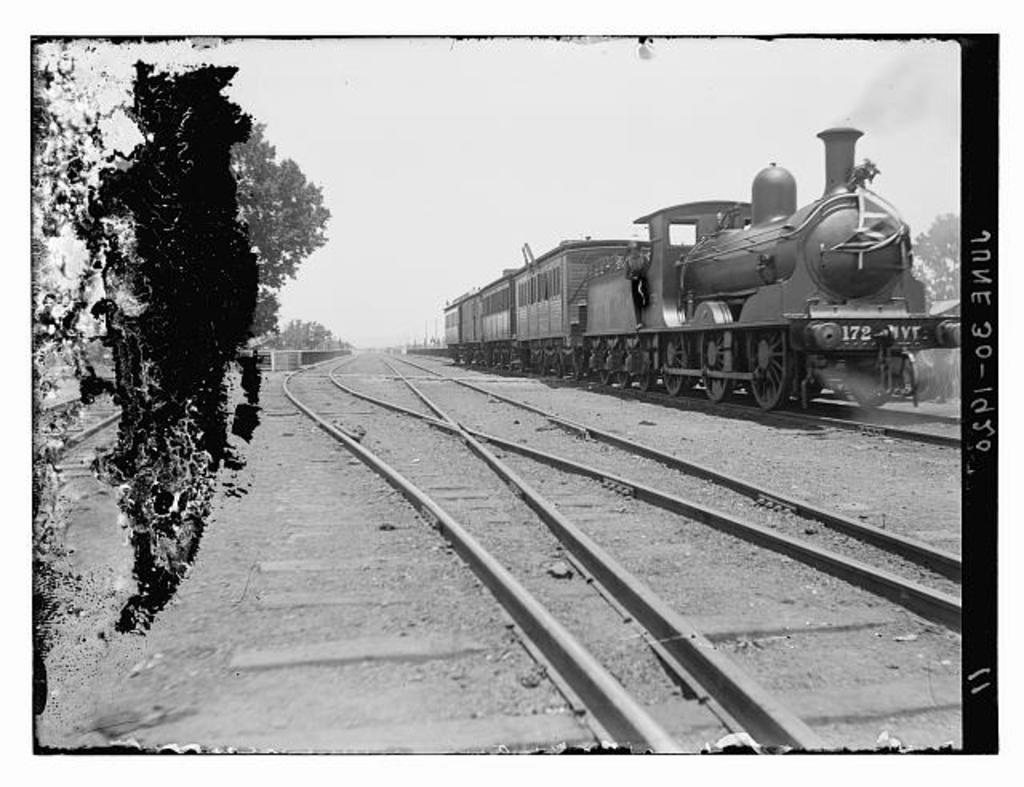Please provide a concise description of this image. This is a black and white image in this image on the right side there is a train, at the bottom there is a railway track and on the left side there are some trees. And on the right side of the image there is some text. 